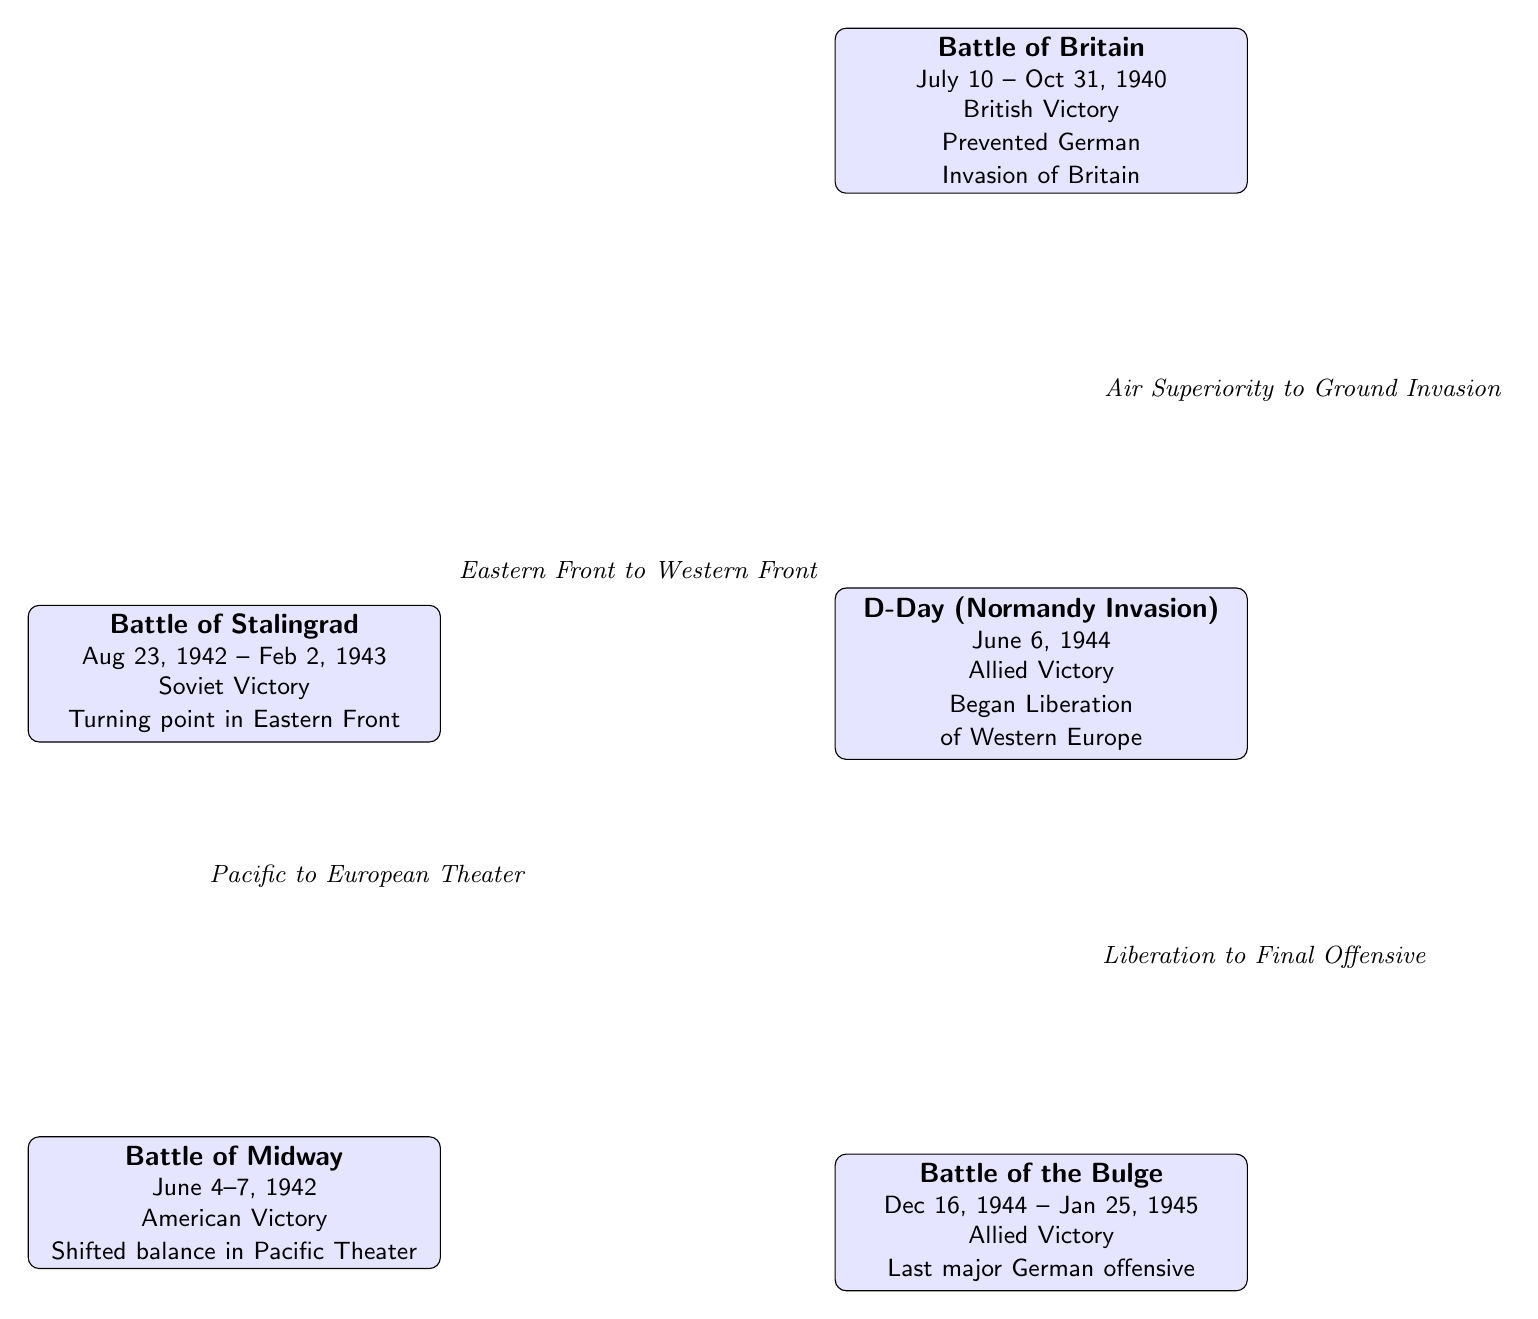What is the first battle listed in the diagram? The diagram starts with the Battle of Stalingrad at the top left, as it is the first node mentioned in the visual representation.
Answer: Battle of Stalingrad How many battles are depicted in the diagram? There are a total of five battles shown in the diagram, each represented as a separate node.
Answer: 5 Which battle represents a pivotal victory in the Pacific Theater? The Battle of Midway, located below the Battle of Stalingrad and above the D-Day battle, is noted as shifting the balance in the Pacific Theater.
Answer: Battle of Midway What was the outcome of the D-Day battle? The diagram indicates that the D-Day battle resulted in an Allied victory, as stated directly within the node representing that battle.
Answer: Allied Victory What does the connection from the Battle of Britain to D-Day signify? The connection indicates that the Battle of Britain contributed to establishing air superiority, which was critical for the subsequent ground invasion at D-Day.
Answer: Air Superiority to Ground Invasion Which battle marked the last major German offensive? The Battle of the Bulge is indicated in the diagram as the last major German offensive, according to the description in its corresponding node.
Answer: Battle of the Bulge Which battles are connected to the D-Day (Normandy Invasion)? The battles connected to D-Day are the Battle of Stalingrad and the Battle of the Bulge, as shown by the arrows leading towards it.
Answer: Battle of Stalingrad, Battle of the Bulge What event is described as a turning point in the Eastern Front? The Battle of Stalingrad is identified in the diagram as a turning point in the Eastern Front, based on the information provided in its node.
Answer: Turning point in Eastern Front What is the relationship between the Battle of Midway and the Normandy Invasion? The connection suggests that the American victory at the Battle of Midway, occurring earlier, shifted the balance in the Pacific Theater, indirectly impacting the strategic decisions leading to the Normandy Invasion.
Answer: Pacific to European Theater 